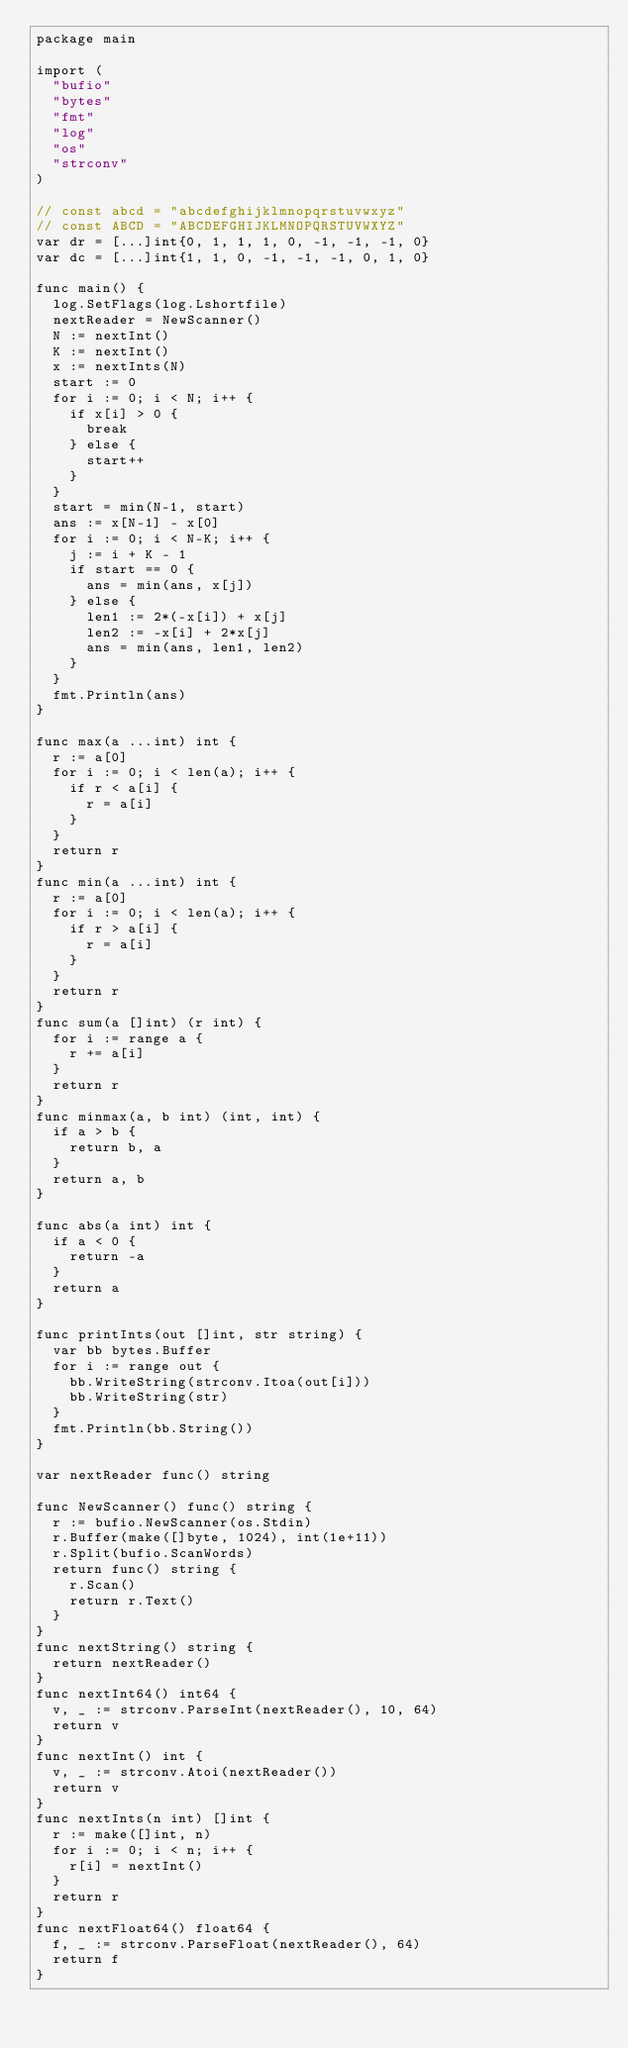Convert code to text. <code><loc_0><loc_0><loc_500><loc_500><_Go_>package main

import (
	"bufio"
	"bytes"
	"fmt"
	"log"
	"os"
	"strconv"
)

// const abcd = "abcdefghijklmnopqrstuvwxyz"
// const ABCD = "ABCDEFGHIJKLMNOPQRSTUVWXYZ"
var dr = [...]int{0, 1, 1, 1, 0, -1, -1, -1, 0}
var dc = [...]int{1, 1, 0, -1, -1, -1, 0, 1, 0}

func main() {
	log.SetFlags(log.Lshortfile)
	nextReader = NewScanner()
	N := nextInt()
	K := nextInt()
	x := nextInts(N)
	start := 0
	for i := 0; i < N; i++ {
		if x[i] > 0 {
			break
		} else {
			start++
		}
	}
	start = min(N-1, start)
	ans := x[N-1] - x[0]
	for i := 0; i < N-K; i++ {
		j := i + K - 1
		if start == 0 {
			ans = min(ans, x[j])
		} else {
			len1 := 2*(-x[i]) + x[j]
			len2 := -x[i] + 2*x[j]
			ans = min(ans, len1, len2)
		}
	}
	fmt.Println(ans)
}

func max(a ...int) int {
	r := a[0]
	for i := 0; i < len(a); i++ {
		if r < a[i] {
			r = a[i]
		}
	}
	return r
}
func min(a ...int) int {
	r := a[0]
	for i := 0; i < len(a); i++ {
		if r > a[i] {
			r = a[i]
		}
	}
	return r
}
func sum(a []int) (r int) {
	for i := range a {
		r += a[i]
	}
	return r
}
func minmax(a, b int) (int, int) {
	if a > b {
		return b, a
	}
	return a, b
}

func abs(a int) int {
	if a < 0 {
		return -a
	}
	return a
}

func printInts(out []int, str string) {
	var bb bytes.Buffer
	for i := range out {
		bb.WriteString(strconv.Itoa(out[i]))
		bb.WriteString(str)
	}
	fmt.Println(bb.String())
}

var nextReader func() string

func NewScanner() func() string {
	r := bufio.NewScanner(os.Stdin)
	r.Buffer(make([]byte, 1024), int(1e+11))
	r.Split(bufio.ScanWords)
	return func() string {
		r.Scan()
		return r.Text()
	}
}
func nextString() string {
	return nextReader()
}
func nextInt64() int64 {
	v, _ := strconv.ParseInt(nextReader(), 10, 64)
	return v
}
func nextInt() int {
	v, _ := strconv.Atoi(nextReader())
	return v
}
func nextInts(n int) []int {
	r := make([]int, n)
	for i := 0; i < n; i++ {
		r[i] = nextInt()
	}
	return r
}
func nextFloat64() float64 {
	f, _ := strconv.ParseFloat(nextReader(), 64)
	return f
}</code> 